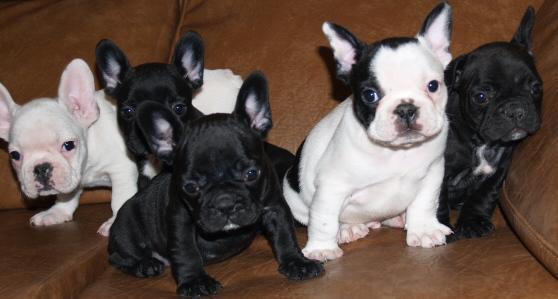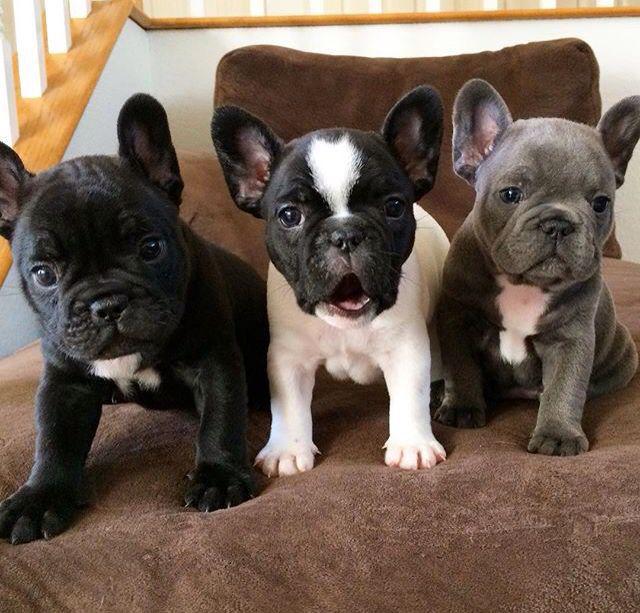The first image is the image on the left, the second image is the image on the right. Examine the images to the left and right. Is the description "One of the dogs is biting a stuffed animal." accurate? Answer yes or no. No. The first image is the image on the left, the second image is the image on the right. Examine the images to the left and right. Is the description "In one of the image the dog is on the grass." accurate? Answer yes or no. No. The first image is the image on the left, the second image is the image on the right. For the images shown, is this caption "There are three dogs" true? Answer yes or no. No. The first image is the image on the left, the second image is the image on the right. Assess this claim about the two images: "There are exactly three puppies.". Correct or not? Answer yes or no. No. 